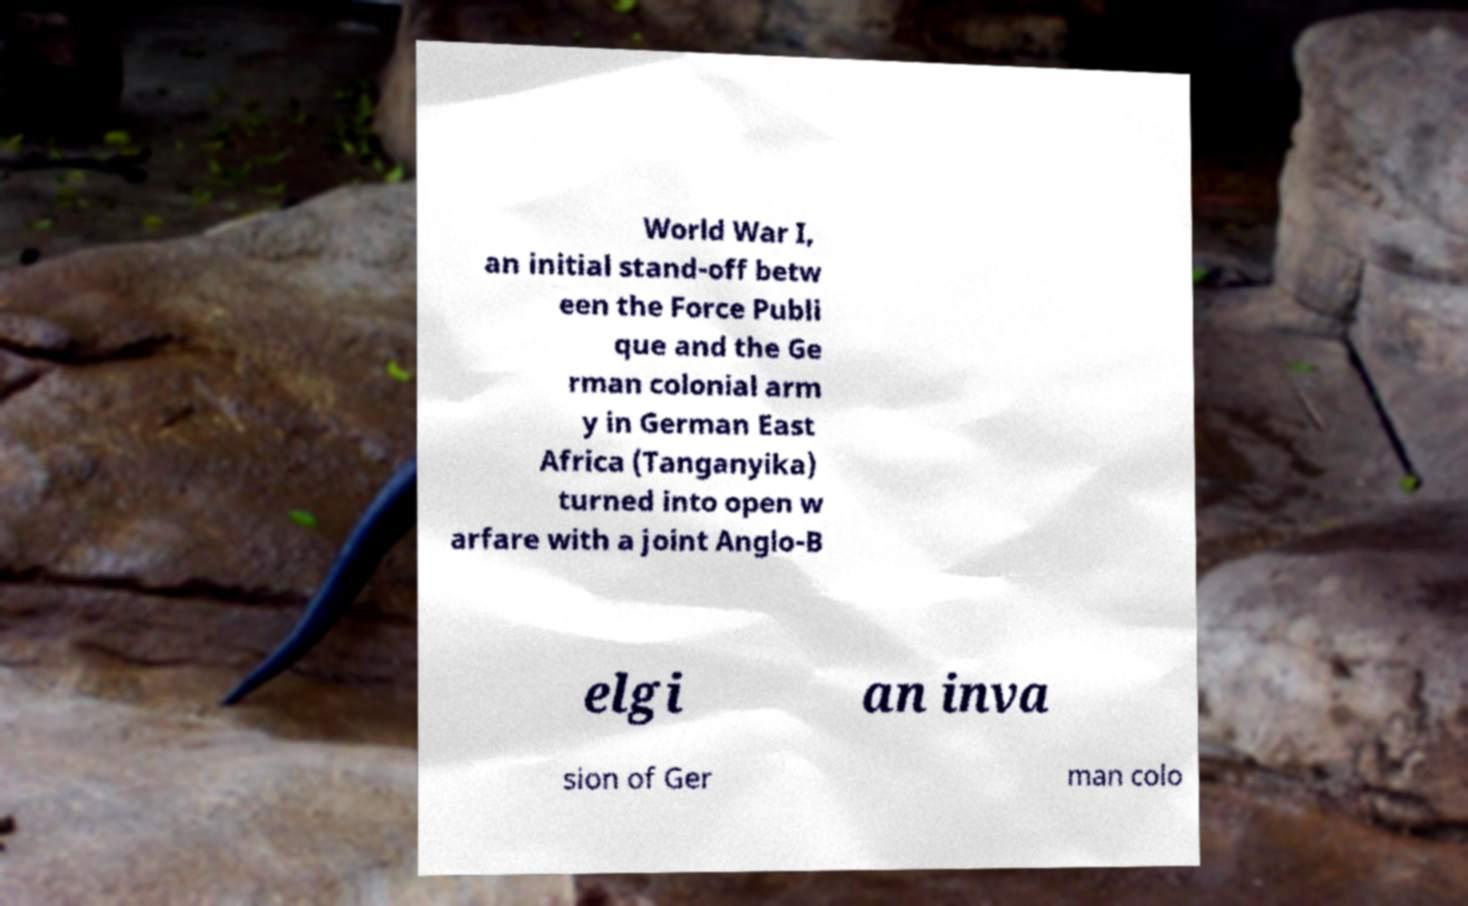Please identify and transcribe the text found in this image. World War I, an initial stand-off betw een the Force Publi que and the Ge rman colonial arm y in German East Africa (Tanganyika) turned into open w arfare with a joint Anglo-B elgi an inva sion of Ger man colo 